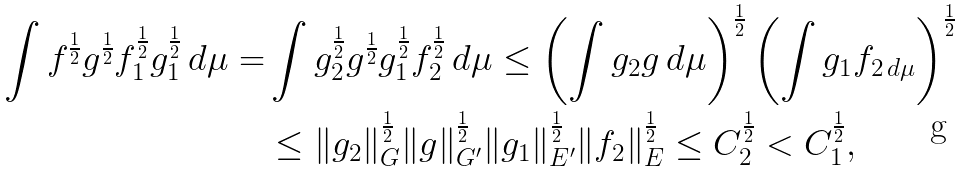Convert formula to latex. <formula><loc_0><loc_0><loc_500><loc_500>\int f ^ { \frac { 1 } { 2 } } g ^ { \frac { 1 } { 2 } } f _ { 1 } ^ { \frac { 1 } { 2 } } g _ { 1 } ^ { \frac { 1 } { 2 } } \, d \mu = & \int g _ { 2 } ^ { \frac { 1 } { 2 } } g ^ { \frac { 1 } { 2 } } g _ { 1 } ^ { \frac { 1 } { 2 } } f _ { 2 } ^ { \frac { 1 } { 2 } } \, d \mu \leq \left ( \int g _ { 2 } g \, d \mu \right ) ^ { \frac { 1 } { 2 } } \left ( \int g _ { 1 } f _ { 2 \, d \mu } \right ) ^ { \frac { 1 } { 2 } } \\ & \leq \| g _ { 2 } \| _ { G } ^ { \frac { 1 } { 2 } } \| g \| _ { G ^ { \prime } } ^ { \frac { 1 } { 2 } } \| g _ { 1 } \| _ { E ^ { \prime } } ^ { \frac { 1 } { 2 } } \| f _ { 2 } \| _ { E } ^ { \frac { 1 } { 2 } } \leq C _ { 2 } ^ { \frac { 1 } { 2 } } < C _ { 1 } ^ { \frac { 1 } { 2 } } ,</formula> 